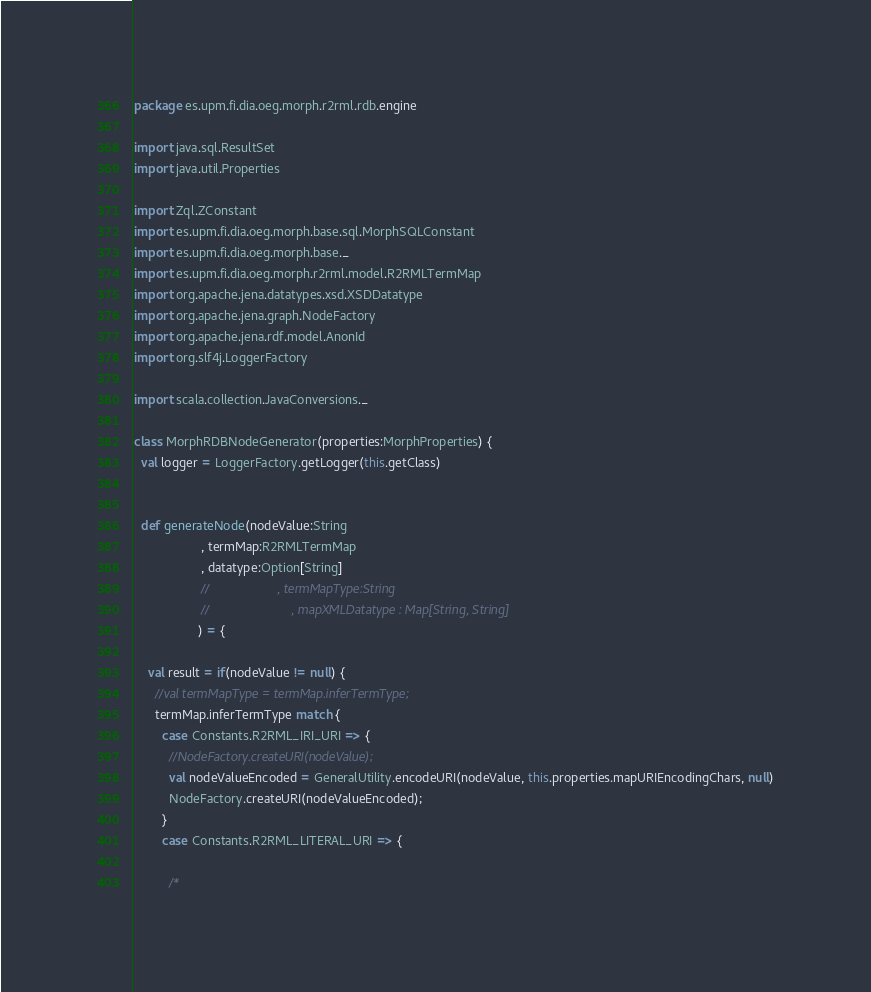<code> <loc_0><loc_0><loc_500><loc_500><_Scala_>package es.upm.fi.dia.oeg.morph.r2rml.rdb.engine

import java.sql.ResultSet
import java.util.Properties

import Zql.ZConstant
import es.upm.fi.dia.oeg.morph.base.sql.MorphSQLConstant
import es.upm.fi.dia.oeg.morph.base._
import es.upm.fi.dia.oeg.morph.r2rml.model.R2RMLTermMap
import org.apache.jena.datatypes.xsd.XSDDatatype
import org.apache.jena.graph.NodeFactory
import org.apache.jena.rdf.model.AnonId
import org.slf4j.LoggerFactory

import scala.collection.JavaConversions._

class MorphRDBNodeGenerator(properties:MorphProperties) {
  val logger = LoggerFactory.getLogger(this.getClass)


  def generateNode(nodeValue:String
                   , termMap:R2RMLTermMap
                   , datatype:Option[String]
                   //                   , termMapType:String
                   //                       , mapXMLDatatype : Map[String, String]
                  ) = {

    val result = if(nodeValue != null) {
      //val termMapType = termMap.inferTermType;
      termMap.inferTermType match {
        case Constants.R2RML_IRI_URI => {
          //NodeFactory.createURI(nodeValue);
          val nodeValueEncoded = GeneralUtility.encodeURI(nodeValue, this.properties.mapURIEncodingChars, null)
          NodeFactory.createURI(nodeValueEncoded);
        }
        case Constants.R2RML_LITERAL_URI => {

          /*</code> 